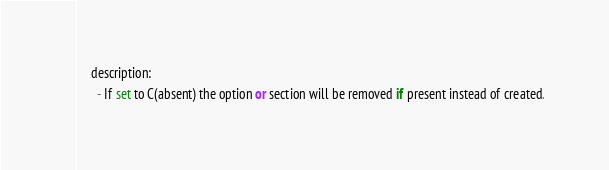<code> <loc_0><loc_0><loc_500><loc_500><_Python_>    description:
      - If set to C(absent) the option or section will be removed if present instead of created.</code> 